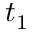Convert formula to latex. <formula><loc_0><loc_0><loc_500><loc_500>t _ { 1 }</formula> 